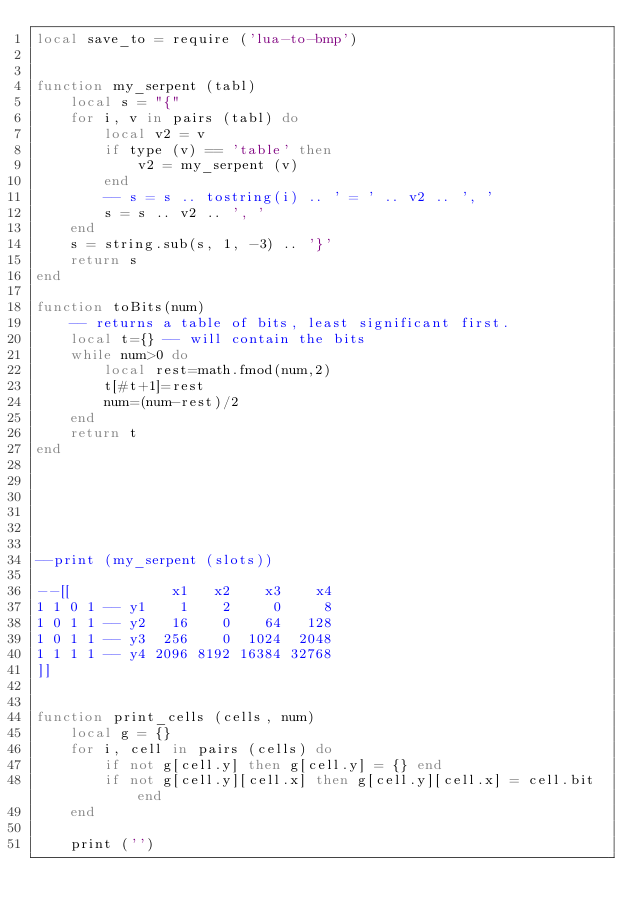Convert code to text. <code><loc_0><loc_0><loc_500><loc_500><_Lua_>local save_to = require ('lua-to-bmp')


function my_serpent (tabl)
	local s = "{"
	for i, v in pairs (tabl) do
		local v2 = v
		if type (v) == 'table' then
			v2 = my_serpent (v)
		end
		-- s = s .. tostring(i) .. ' = ' .. v2 .. ', ' 
		s = s .. v2 .. ', ' 
	end
	s = string.sub(s, 1, -3) .. '}'
	return s
end

function toBits(num)
    -- returns a table of bits, least significant first.
    local t={} -- will contain the bits
    while num>0 do
        local rest=math.fmod(num,2)
        t[#t+1]=rest
        num=(num-rest)/2
    end
    return t
end






--print (my_serpent (slots))

--[[            x1   x2    x3    x4
1 1 0 1 -- y1    1    2     0     8
1 0 1 1 -- y2   16    0    64   128
1 0 1 1 -- y3  256    0  1024  2048
1 1 1 1 -- y4 2096 8192 16384 32768
]]


function print_cells (cells, num)
	local g = {}
	for i, cell in pairs (cells) do
		if not g[cell.y] then g[cell.y] = {} end
		if not g[cell.y][cell.x] then g[cell.y][cell.x] = cell.bit end
	end
	
	print ('')</code> 